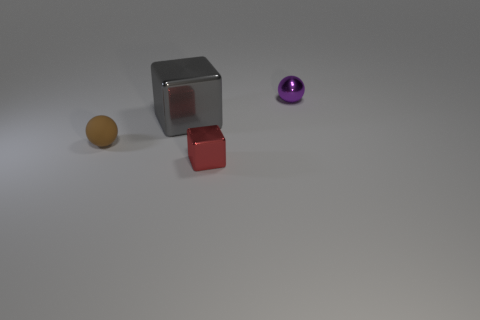Subtract 1 spheres. How many spheres are left? 1 Add 2 tiny metal cubes. How many objects exist? 6 Subtract all brown balls. How many balls are left? 1 Subtract 1 brown spheres. How many objects are left? 3 Subtract all purple spheres. Subtract all gray blocks. How many spheres are left? 1 Subtract all gray blocks. How many blue spheres are left? 0 Subtract all red metallic cubes. Subtract all small brown objects. How many objects are left? 2 Add 3 gray objects. How many gray objects are left? 4 Add 3 metallic cubes. How many metallic cubes exist? 5 